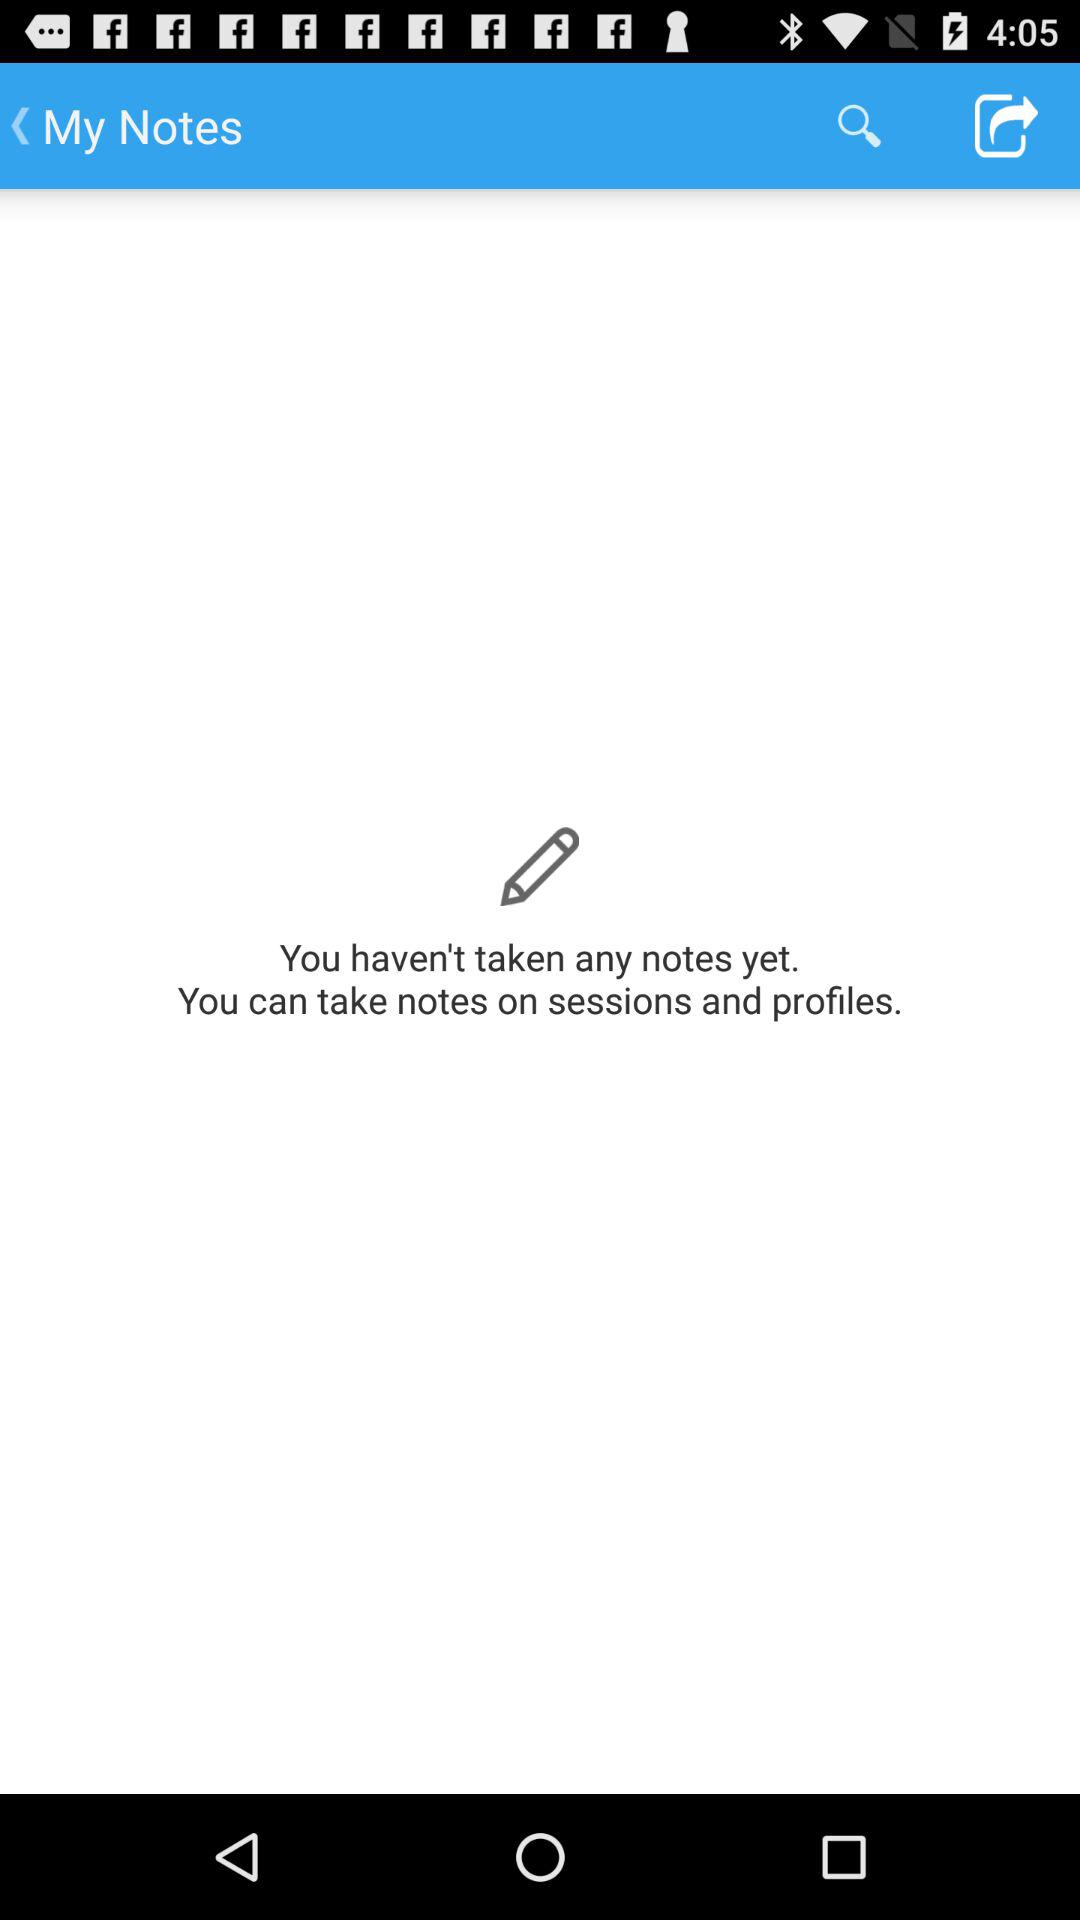How many notes have I taken?
Answer the question using a single word or phrase. 0 